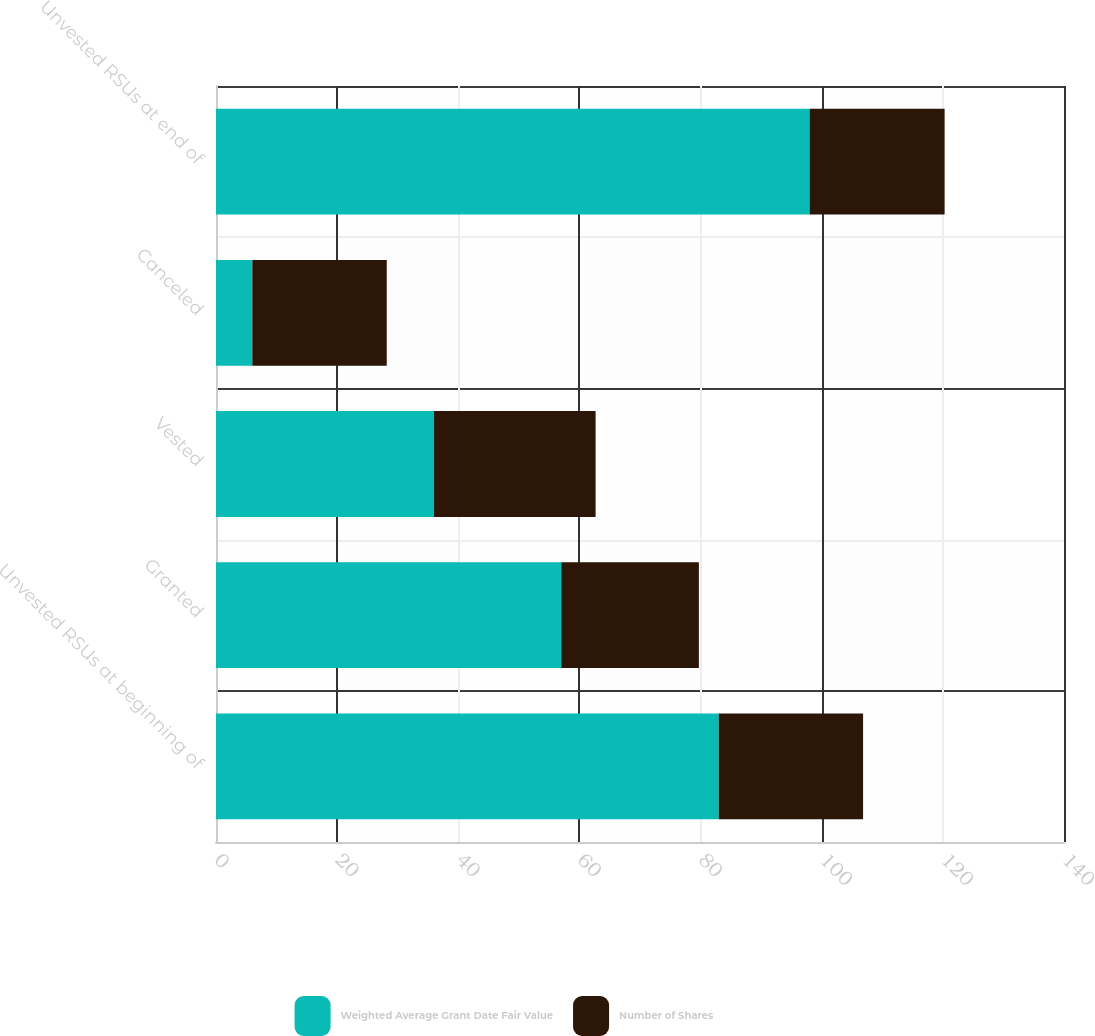Convert chart. <chart><loc_0><loc_0><loc_500><loc_500><stacked_bar_chart><ecel><fcel>Unvested RSUs at beginning of<fcel>Granted<fcel>Vested<fcel>Canceled<fcel>Unvested RSUs at end of<nl><fcel>Weighted Average Grant Date Fair Value<fcel>83<fcel>57<fcel>36<fcel>6<fcel>98<nl><fcel>Number of Shares<fcel>23.83<fcel>22.72<fcel>26.67<fcel>22.19<fcel>22.29<nl></chart> 